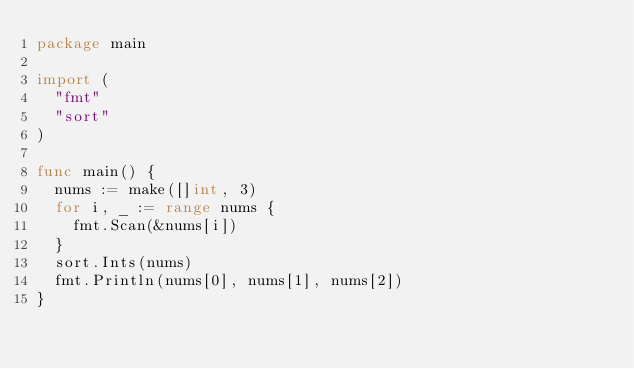Convert code to text. <code><loc_0><loc_0><loc_500><loc_500><_Go_>package main

import (
	"fmt"
	"sort"
)

func main() {
	nums := make([]int, 3)
	for i, _ := range nums {
		fmt.Scan(&nums[i])
	}
	sort.Ints(nums)
	fmt.Println(nums[0], nums[1], nums[2])
}

</code> 